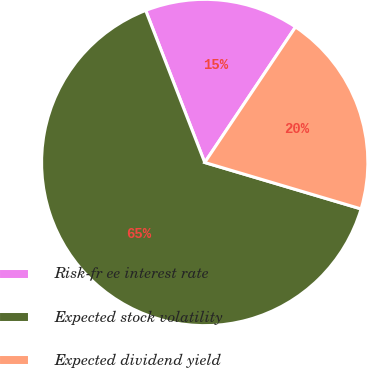<chart> <loc_0><loc_0><loc_500><loc_500><pie_chart><fcel>Risk-fr ee interest rate<fcel>Expected stock volatility<fcel>Expected dividend yield<nl><fcel>15.29%<fcel>64.51%<fcel>20.2%<nl></chart> 